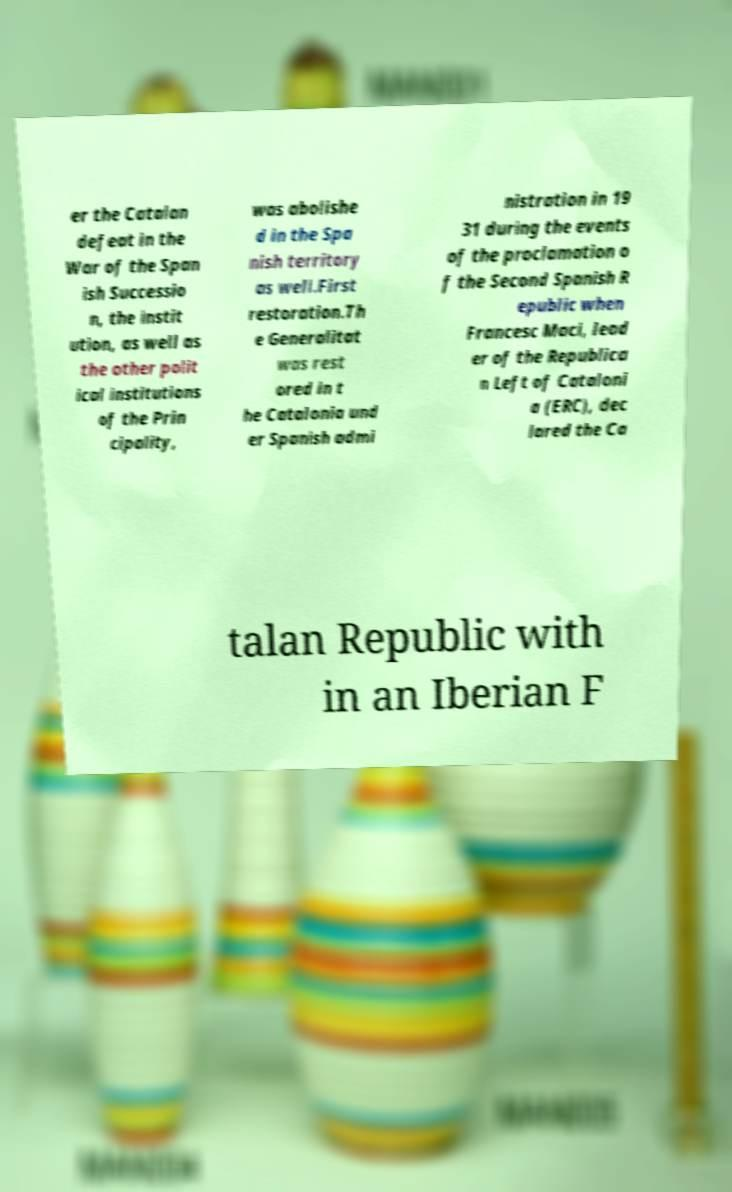For documentation purposes, I need the text within this image transcribed. Could you provide that? er the Catalan defeat in the War of the Span ish Successio n, the instit ution, as well as the other polit ical institutions of the Prin cipality, was abolishe d in the Spa nish territory as well.First restoration.Th e Generalitat was rest ored in t he Catalonia und er Spanish admi nistration in 19 31 during the events of the proclamation o f the Second Spanish R epublic when Francesc Maci, lead er of the Republica n Left of Cataloni a (ERC), dec lared the Ca talan Republic with in an Iberian F 